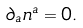<formula> <loc_0><loc_0><loc_500><loc_500>\partial _ { a } n ^ { a } = 0 .</formula> 